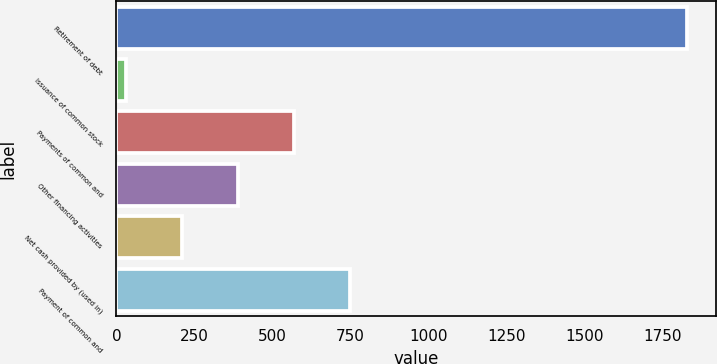Convert chart. <chart><loc_0><loc_0><loc_500><loc_500><bar_chart><fcel>Retirement of debt<fcel>Issuance of common stock<fcel>Payments of common and<fcel>Other financing activities<fcel>Net cash provided by (used in)<fcel>Payment of common and<nl><fcel>1829<fcel>30<fcel>569.7<fcel>389.8<fcel>209.9<fcel>749.6<nl></chart> 